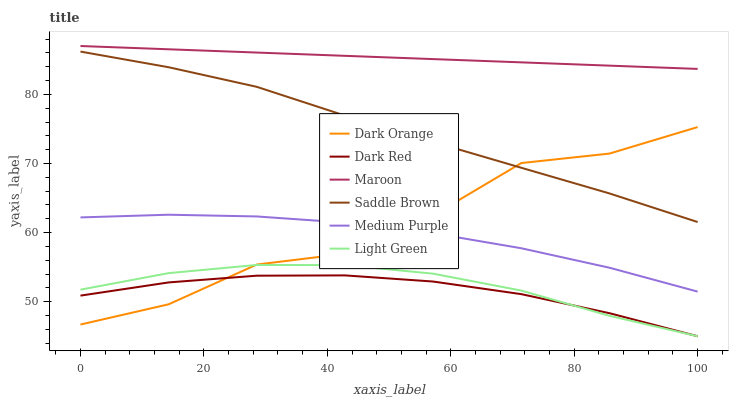Does Dark Red have the minimum area under the curve?
Answer yes or no. Yes. Does Maroon have the maximum area under the curve?
Answer yes or no. Yes. Does Maroon have the minimum area under the curve?
Answer yes or no. No. Does Dark Red have the maximum area under the curve?
Answer yes or no. No. Is Maroon the smoothest?
Answer yes or no. Yes. Is Dark Orange the roughest?
Answer yes or no. Yes. Is Dark Red the smoothest?
Answer yes or no. No. Is Dark Red the roughest?
Answer yes or no. No. Does Dark Red have the lowest value?
Answer yes or no. Yes. Does Maroon have the lowest value?
Answer yes or no. No. Does Maroon have the highest value?
Answer yes or no. Yes. Does Dark Red have the highest value?
Answer yes or no. No. Is Light Green less than Medium Purple?
Answer yes or no. Yes. Is Maroon greater than Medium Purple?
Answer yes or no. Yes. Does Light Green intersect Dark Red?
Answer yes or no. Yes. Is Light Green less than Dark Red?
Answer yes or no. No. Is Light Green greater than Dark Red?
Answer yes or no. No. Does Light Green intersect Medium Purple?
Answer yes or no. No. 